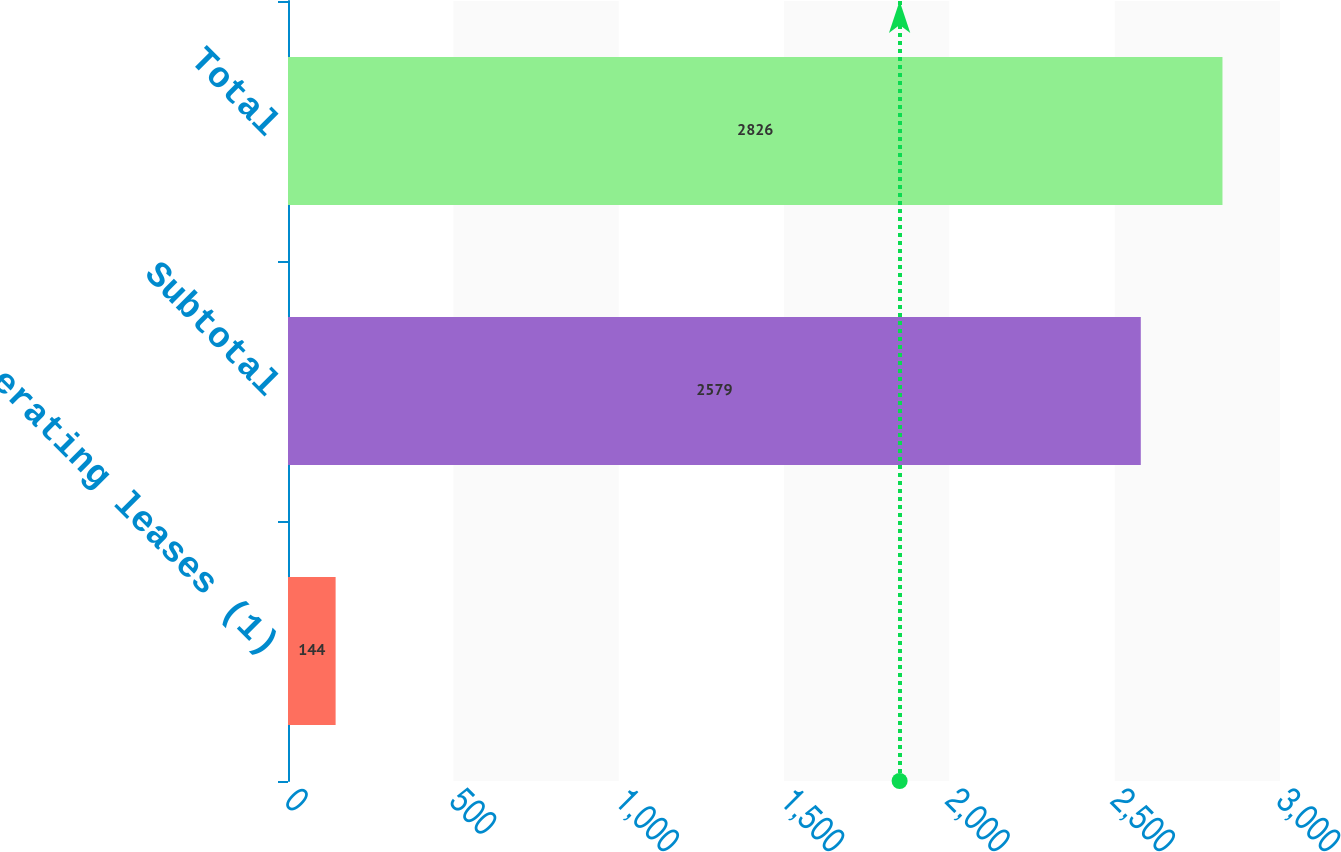Convert chart. <chart><loc_0><loc_0><loc_500><loc_500><bar_chart><fcel>Operating leases (1)<fcel>Subtotal<fcel>Total<nl><fcel>144<fcel>2579<fcel>2826<nl></chart> 